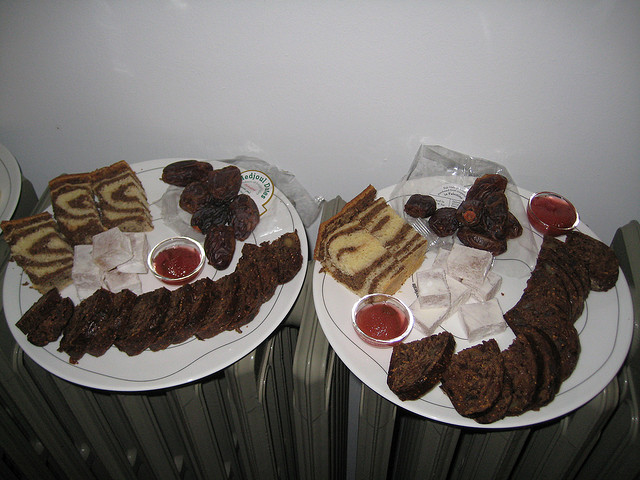<image>What type of bread is shown? I don't know. It could be marble rye, cake, rye, or simply brown. What type of bread is shown? I am not sure what type of bread is shown. It can be seen as cake, marble rye, marble, brown, dessert, rye. 